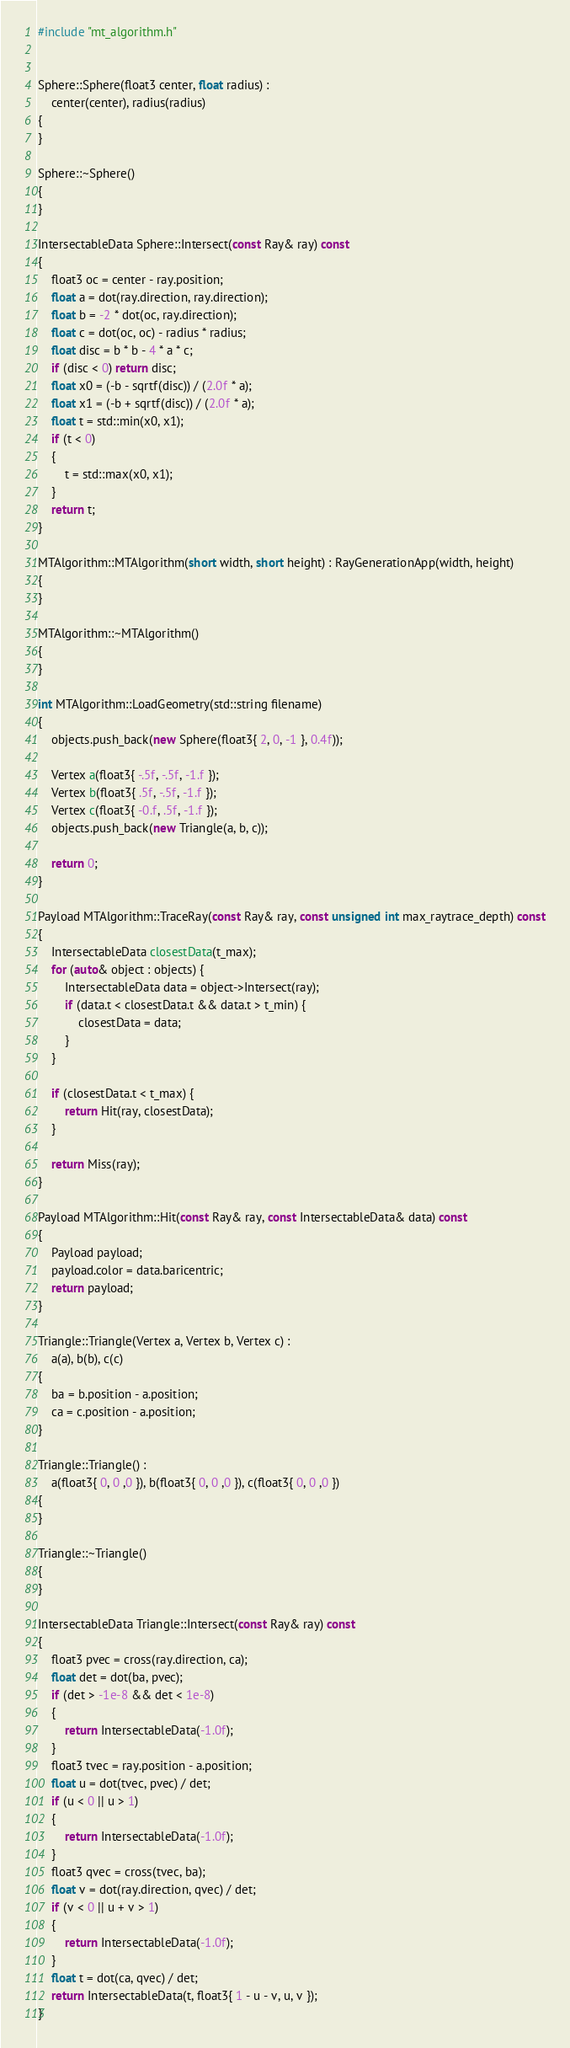<code> <loc_0><loc_0><loc_500><loc_500><_C++_>#include "mt_algorithm.h"


Sphere::Sphere(float3 center, float radius) :
	center(center), radius(radius)
{
}

Sphere::~Sphere()
{
}

IntersectableData Sphere::Intersect(const Ray& ray) const
{
	float3 oc = center - ray.position;
	float a = dot(ray.direction, ray.direction);
	float b = -2 * dot(oc, ray.direction);
	float c = dot(oc, oc) - radius * radius;
	float disc = b * b - 4 * a * c;
	if (disc < 0) return disc;
	float x0 = (-b - sqrtf(disc)) / (2.0f * a);
	float x1 = (-b + sqrtf(disc)) / (2.0f * a);
	float t = std::min(x0, x1);
	if (t < 0)
	{
		t = std::max(x0, x1);
	}
	return t;
}

MTAlgorithm::MTAlgorithm(short width, short height) : RayGenerationApp(width, height)
{
}

MTAlgorithm::~MTAlgorithm()
{
}

int MTAlgorithm::LoadGeometry(std::string filename)
{
	objects.push_back(new Sphere(float3{ 2, 0, -1 }, 0.4f));

	Vertex a(float3{ -.5f, -.5f, -1.f });
	Vertex b(float3{ .5f, -.5f, -1.f });
	Vertex c(float3{ -0.f, .5f, -1.f });
	objects.push_back(new Triangle(a, b, c));

	return 0;
}

Payload MTAlgorithm::TraceRay(const Ray& ray, const unsigned int max_raytrace_depth) const
{
	IntersectableData closestData(t_max);
	for (auto& object : objects) {
		IntersectableData data = object->Intersect(ray);
		if (data.t < closestData.t && data.t > t_min) {
			closestData = data;
		}
	}

	if (closestData.t < t_max) {
		return Hit(ray, closestData);
	}

	return Miss(ray);
}

Payload MTAlgorithm::Hit(const Ray& ray, const IntersectableData& data) const
{
	Payload payload;
	payload.color = data.baricentric;
	return payload;
}

Triangle::Triangle(Vertex a, Vertex b, Vertex c) :
	a(a), b(b), c(c)
{
	ba = b.position - a.position;
	ca = c.position - a.position;
}

Triangle::Triangle() :
	a(float3{ 0, 0 ,0 }), b(float3{ 0, 0 ,0 }), c(float3{ 0, 0 ,0 })
{
}

Triangle::~Triangle()
{
}

IntersectableData Triangle::Intersect(const Ray& ray) const
{
	float3 pvec = cross(ray.direction, ca);
	float det = dot(ba, pvec);
	if (det > -1e-8 && det < 1e-8)
	{
		return IntersectableData(-1.0f);
	}
	float3 tvec = ray.position - a.position;
	float u = dot(tvec, pvec) / det;
	if (u < 0 || u > 1)
	{
		return IntersectableData(-1.0f);
	}
	float3 qvec = cross(tvec, ba);
	float v = dot(ray.direction, qvec) / det;
	if (v < 0 || u + v > 1)
	{
		return IntersectableData(-1.0f);
	}
	float t = dot(ca, qvec) / det;
	return IntersectableData(t, float3{ 1 - u - v, u, v });
}
</code> 